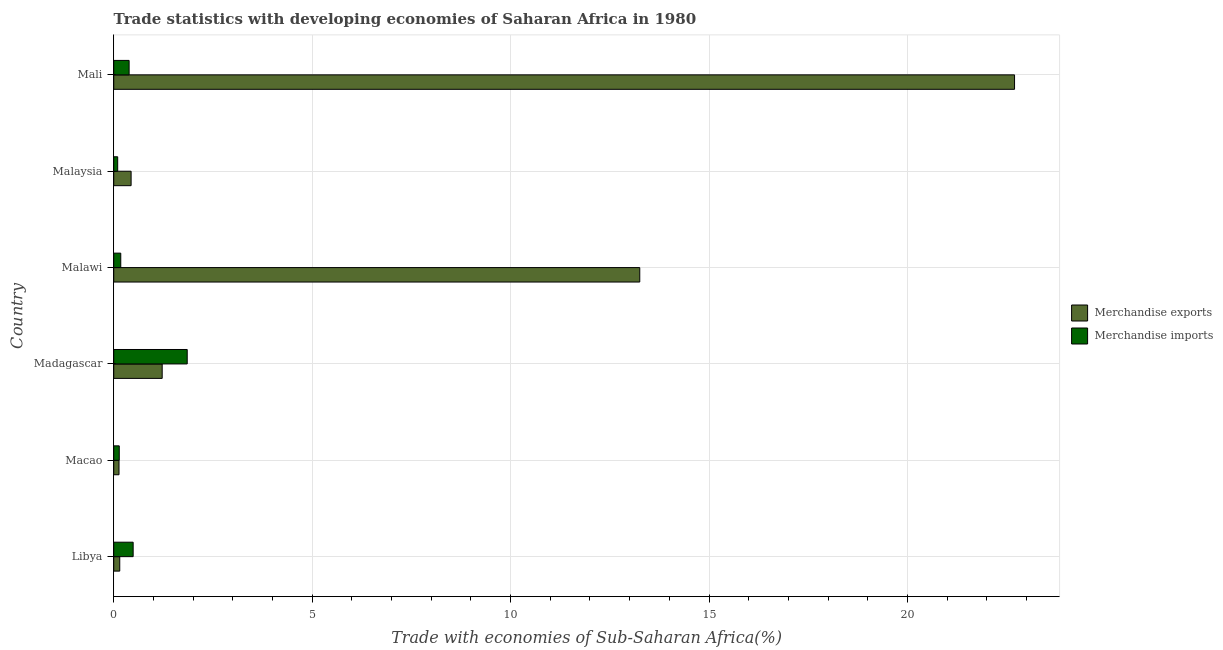How many different coloured bars are there?
Provide a short and direct response. 2. How many groups of bars are there?
Make the answer very short. 6. Are the number of bars on each tick of the Y-axis equal?
Provide a succinct answer. Yes. What is the label of the 1st group of bars from the top?
Offer a very short reply. Mali. In how many cases, is the number of bars for a given country not equal to the number of legend labels?
Provide a succinct answer. 0. What is the merchandise exports in Malawi?
Keep it short and to the point. 13.26. Across all countries, what is the maximum merchandise exports?
Keep it short and to the point. 22.7. Across all countries, what is the minimum merchandise imports?
Your response must be concise. 0.1. In which country was the merchandise exports maximum?
Offer a very short reply. Mali. In which country was the merchandise imports minimum?
Keep it short and to the point. Malaysia. What is the total merchandise imports in the graph?
Make the answer very short. 3.14. What is the difference between the merchandise imports in Mali and the merchandise exports in Macao?
Your response must be concise. 0.25. What is the average merchandise imports per country?
Your answer should be very brief. 0.52. What is the difference between the merchandise exports and merchandise imports in Mali?
Your response must be concise. 22.31. What is the ratio of the merchandise exports in Malawi to that in Malaysia?
Provide a succinct answer. 30.28. Is the difference between the merchandise imports in Libya and Malaysia greater than the difference between the merchandise exports in Libya and Malaysia?
Give a very brief answer. Yes. What is the difference between the highest and the second highest merchandise exports?
Keep it short and to the point. 9.44. What is the difference between the highest and the lowest merchandise exports?
Ensure brevity in your answer.  22.57. In how many countries, is the merchandise imports greater than the average merchandise imports taken over all countries?
Ensure brevity in your answer.  1. Is the sum of the merchandise exports in Libya and Macao greater than the maximum merchandise imports across all countries?
Offer a very short reply. No. What does the 1st bar from the top in Libya represents?
Make the answer very short. Merchandise imports. Are all the bars in the graph horizontal?
Provide a short and direct response. Yes. What is the difference between two consecutive major ticks on the X-axis?
Give a very brief answer. 5. Are the values on the major ticks of X-axis written in scientific E-notation?
Offer a very short reply. No. Does the graph contain any zero values?
Offer a very short reply. No. Where does the legend appear in the graph?
Keep it short and to the point. Center right. How many legend labels are there?
Offer a terse response. 2. What is the title of the graph?
Give a very brief answer. Trade statistics with developing economies of Saharan Africa in 1980. Does "Crop" appear as one of the legend labels in the graph?
Provide a succinct answer. No. What is the label or title of the X-axis?
Give a very brief answer. Trade with economies of Sub-Saharan Africa(%). What is the label or title of the Y-axis?
Provide a short and direct response. Country. What is the Trade with economies of Sub-Saharan Africa(%) in Merchandise exports in Libya?
Give a very brief answer. 0.15. What is the Trade with economies of Sub-Saharan Africa(%) of Merchandise imports in Libya?
Your response must be concise. 0.49. What is the Trade with economies of Sub-Saharan Africa(%) of Merchandise exports in Macao?
Offer a terse response. 0.13. What is the Trade with economies of Sub-Saharan Africa(%) of Merchandise imports in Macao?
Keep it short and to the point. 0.14. What is the Trade with economies of Sub-Saharan Africa(%) of Merchandise exports in Madagascar?
Keep it short and to the point. 1.22. What is the Trade with economies of Sub-Saharan Africa(%) of Merchandise imports in Madagascar?
Provide a short and direct response. 1.85. What is the Trade with economies of Sub-Saharan Africa(%) in Merchandise exports in Malawi?
Make the answer very short. 13.26. What is the Trade with economies of Sub-Saharan Africa(%) in Merchandise imports in Malawi?
Your answer should be very brief. 0.18. What is the Trade with economies of Sub-Saharan Africa(%) in Merchandise exports in Malaysia?
Provide a succinct answer. 0.44. What is the Trade with economies of Sub-Saharan Africa(%) of Merchandise imports in Malaysia?
Give a very brief answer. 0.1. What is the Trade with economies of Sub-Saharan Africa(%) of Merchandise exports in Mali?
Your answer should be compact. 22.7. What is the Trade with economies of Sub-Saharan Africa(%) in Merchandise imports in Mali?
Your response must be concise. 0.39. Across all countries, what is the maximum Trade with economies of Sub-Saharan Africa(%) of Merchandise exports?
Your answer should be very brief. 22.7. Across all countries, what is the maximum Trade with economies of Sub-Saharan Africa(%) in Merchandise imports?
Offer a very short reply. 1.85. Across all countries, what is the minimum Trade with economies of Sub-Saharan Africa(%) of Merchandise exports?
Your response must be concise. 0.13. Across all countries, what is the minimum Trade with economies of Sub-Saharan Africa(%) of Merchandise imports?
Your answer should be compact. 0.1. What is the total Trade with economies of Sub-Saharan Africa(%) of Merchandise exports in the graph?
Your answer should be very brief. 37.9. What is the total Trade with economies of Sub-Saharan Africa(%) of Merchandise imports in the graph?
Give a very brief answer. 3.14. What is the difference between the Trade with economies of Sub-Saharan Africa(%) in Merchandise exports in Libya and that in Macao?
Provide a succinct answer. 0.02. What is the difference between the Trade with economies of Sub-Saharan Africa(%) in Merchandise imports in Libya and that in Macao?
Give a very brief answer. 0.35. What is the difference between the Trade with economies of Sub-Saharan Africa(%) of Merchandise exports in Libya and that in Madagascar?
Ensure brevity in your answer.  -1.07. What is the difference between the Trade with economies of Sub-Saharan Africa(%) of Merchandise imports in Libya and that in Madagascar?
Make the answer very short. -1.36. What is the difference between the Trade with economies of Sub-Saharan Africa(%) in Merchandise exports in Libya and that in Malawi?
Keep it short and to the point. -13.1. What is the difference between the Trade with economies of Sub-Saharan Africa(%) of Merchandise imports in Libya and that in Malawi?
Your answer should be very brief. 0.31. What is the difference between the Trade with economies of Sub-Saharan Africa(%) in Merchandise exports in Libya and that in Malaysia?
Ensure brevity in your answer.  -0.29. What is the difference between the Trade with economies of Sub-Saharan Africa(%) in Merchandise imports in Libya and that in Malaysia?
Your answer should be very brief. 0.39. What is the difference between the Trade with economies of Sub-Saharan Africa(%) of Merchandise exports in Libya and that in Mali?
Give a very brief answer. -22.55. What is the difference between the Trade with economies of Sub-Saharan Africa(%) of Merchandise imports in Libya and that in Mali?
Your answer should be very brief. 0.1. What is the difference between the Trade with economies of Sub-Saharan Africa(%) in Merchandise exports in Macao and that in Madagascar?
Your answer should be very brief. -1.09. What is the difference between the Trade with economies of Sub-Saharan Africa(%) in Merchandise imports in Macao and that in Madagascar?
Give a very brief answer. -1.71. What is the difference between the Trade with economies of Sub-Saharan Africa(%) of Merchandise exports in Macao and that in Malawi?
Keep it short and to the point. -13.12. What is the difference between the Trade with economies of Sub-Saharan Africa(%) of Merchandise imports in Macao and that in Malawi?
Make the answer very short. -0.04. What is the difference between the Trade with economies of Sub-Saharan Africa(%) of Merchandise exports in Macao and that in Malaysia?
Your response must be concise. -0.3. What is the difference between the Trade with economies of Sub-Saharan Africa(%) in Merchandise exports in Macao and that in Mali?
Your response must be concise. -22.57. What is the difference between the Trade with economies of Sub-Saharan Africa(%) in Merchandise imports in Macao and that in Mali?
Provide a short and direct response. -0.25. What is the difference between the Trade with economies of Sub-Saharan Africa(%) of Merchandise exports in Madagascar and that in Malawi?
Offer a very short reply. -12.03. What is the difference between the Trade with economies of Sub-Saharan Africa(%) of Merchandise imports in Madagascar and that in Malawi?
Offer a terse response. 1.67. What is the difference between the Trade with economies of Sub-Saharan Africa(%) of Merchandise exports in Madagascar and that in Malaysia?
Your answer should be very brief. 0.78. What is the difference between the Trade with economies of Sub-Saharan Africa(%) of Merchandise imports in Madagascar and that in Malaysia?
Your response must be concise. 1.75. What is the difference between the Trade with economies of Sub-Saharan Africa(%) in Merchandise exports in Madagascar and that in Mali?
Your answer should be compact. -21.48. What is the difference between the Trade with economies of Sub-Saharan Africa(%) in Merchandise imports in Madagascar and that in Mali?
Your answer should be very brief. 1.46. What is the difference between the Trade with economies of Sub-Saharan Africa(%) of Merchandise exports in Malawi and that in Malaysia?
Your response must be concise. 12.82. What is the difference between the Trade with economies of Sub-Saharan Africa(%) of Merchandise imports in Malawi and that in Malaysia?
Give a very brief answer. 0.08. What is the difference between the Trade with economies of Sub-Saharan Africa(%) of Merchandise exports in Malawi and that in Mali?
Your answer should be compact. -9.44. What is the difference between the Trade with economies of Sub-Saharan Africa(%) in Merchandise imports in Malawi and that in Mali?
Provide a succinct answer. -0.21. What is the difference between the Trade with economies of Sub-Saharan Africa(%) in Merchandise exports in Malaysia and that in Mali?
Offer a very short reply. -22.26. What is the difference between the Trade with economies of Sub-Saharan Africa(%) in Merchandise imports in Malaysia and that in Mali?
Ensure brevity in your answer.  -0.29. What is the difference between the Trade with economies of Sub-Saharan Africa(%) in Merchandise exports in Libya and the Trade with economies of Sub-Saharan Africa(%) in Merchandise imports in Macao?
Your response must be concise. 0.01. What is the difference between the Trade with economies of Sub-Saharan Africa(%) of Merchandise exports in Libya and the Trade with economies of Sub-Saharan Africa(%) of Merchandise imports in Madagascar?
Make the answer very short. -1.7. What is the difference between the Trade with economies of Sub-Saharan Africa(%) of Merchandise exports in Libya and the Trade with economies of Sub-Saharan Africa(%) of Merchandise imports in Malawi?
Make the answer very short. -0.03. What is the difference between the Trade with economies of Sub-Saharan Africa(%) of Merchandise exports in Libya and the Trade with economies of Sub-Saharan Africa(%) of Merchandise imports in Malaysia?
Ensure brevity in your answer.  0.05. What is the difference between the Trade with economies of Sub-Saharan Africa(%) in Merchandise exports in Libya and the Trade with economies of Sub-Saharan Africa(%) in Merchandise imports in Mali?
Provide a succinct answer. -0.24. What is the difference between the Trade with economies of Sub-Saharan Africa(%) of Merchandise exports in Macao and the Trade with economies of Sub-Saharan Africa(%) of Merchandise imports in Madagascar?
Provide a succinct answer. -1.72. What is the difference between the Trade with economies of Sub-Saharan Africa(%) in Merchandise exports in Macao and the Trade with economies of Sub-Saharan Africa(%) in Merchandise imports in Malawi?
Make the answer very short. -0.04. What is the difference between the Trade with economies of Sub-Saharan Africa(%) of Merchandise exports in Macao and the Trade with economies of Sub-Saharan Africa(%) of Merchandise imports in Malaysia?
Provide a short and direct response. 0.03. What is the difference between the Trade with economies of Sub-Saharan Africa(%) of Merchandise exports in Macao and the Trade with economies of Sub-Saharan Africa(%) of Merchandise imports in Mali?
Your answer should be very brief. -0.25. What is the difference between the Trade with economies of Sub-Saharan Africa(%) in Merchandise exports in Madagascar and the Trade with economies of Sub-Saharan Africa(%) in Merchandise imports in Malawi?
Make the answer very short. 1.04. What is the difference between the Trade with economies of Sub-Saharan Africa(%) in Merchandise exports in Madagascar and the Trade with economies of Sub-Saharan Africa(%) in Merchandise imports in Malaysia?
Offer a terse response. 1.12. What is the difference between the Trade with economies of Sub-Saharan Africa(%) of Merchandise exports in Madagascar and the Trade with economies of Sub-Saharan Africa(%) of Merchandise imports in Mali?
Your answer should be compact. 0.83. What is the difference between the Trade with economies of Sub-Saharan Africa(%) in Merchandise exports in Malawi and the Trade with economies of Sub-Saharan Africa(%) in Merchandise imports in Malaysia?
Your response must be concise. 13.16. What is the difference between the Trade with economies of Sub-Saharan Africa(%) in Merchandise exports in Malawi and the Trade with economies of Sub-Saharan Africa(%) in Merchandise imports in Mali?
Your response must be concise. 12.87. What is the difference between the Trade with economies of Sub-Saharan Africa(%) in Merchandise exports in Malaysia and the Trade with economies of Sub-Saharan Africa(%) in Merchandise imports in Mali?
Give a very brief answer. 0.05. What is the average Trade with economies of Sub-Saharan Africa(%) in Merchandise exports per country?
Make the answer very short. 6.32. What is the average Trade with economies of Sub-Saharan Africa(%) in Merchandise imports per country?
Make the answer very short. 0.52. What is the difference between the Trade with economies of Sub-Saharan Africa(%) of Merchandise exports and Trade with economies of Sub-Saharan Africa(%) of Merchandise imports in Libya?
Your answer should be very brief. -0.34. What is the difference between the Trade with economies of Sub-Saharan Africa(%) of Merchandise exports and Trade with economies of Sub-Saharan Africa(%) of Merchandise imports in Macao?
Offer a terse response. -0.01. What is the difference between the Trade with economies of Sub-Saharan Africa(%) in Merchandise exports and Trade with economies of Sub-Saharan Africa(%) in Merchandise imports in Madagascar?
Your answer should be very brief. -0.63. What is the difference between the Trade with economies of Sub-Saharan Africa(%) in Merchandise exports and Trade with economies of Sub-Saharan Africa(%) in Merchandise imports in Malawi?
Offer a very short reply. 13.08. What is the difference between the Trade with economies of Sub-Saharan Africa(%) of Merchandise exports and Trade with economies of Sub-Saharan Africa(%) of Merchandise imports in Malaysia?
Provide a succinct answer. 0.34. What is the difference between the Trade with economies of Sub-Saharan Africa(%) of Merchandise exports and Trade with economies of Sub-Saharan Africa(%) of Merchandise imports in Mali?
Your response must be concise. 22.31. What is the ratio of the Trade with economies of Sub-Saharan Africa(%) in Merchandise exports in Libya to that in Macao?
Your answer should be very brief. 1.14. What is the ratio of the Trade with economies of Sub-Saharan Africa(%) in Merchandise imports in Libya to that in Macao?
Offer a very short reply. 3.51. What is the ratio of the Trade with economies of Sub-Saharan Africa(%) of Merchandise exports in Libya to that in Madagascar?
Provide a succinct answer. 0.12. What is the ratio of the Trade with economies of Sub-Saharan Africa(%) of Merchandise imports in Libya to that in Madagascar?
Provide a succinct answer. 0.26. What is the ratio of the Trade with economies of Sub-Saharan Africa(%) in Merchandise exports in Libya to that in Malawi?
Provide a succinct answer. 0.01. What is the ratio of the Trade with economies of Sub-Saharan Africa(%) of Merchandise imports in Libya to that in Malawi?
Make the answer very short. 2.76. What is the ratio of the Trade with economies of Sub-Saharan Africa(%) in Merchandise exports in Libya to that in Malaysia?
Your answer should be compact. 0.35. What is the ratio of the Trade with economies of Sub-Saharan Africa(%) of Merchandise imports in Libya to that in Malaysia?
Your response must be concise. 4.93. What is the ratio of the Trade with economies of Sub-Saharan Africa(%) in Merchandise exports in Libya to that in Mali?
Your answer should be compact. 0.01. What is the ratio of the Trade with economies of Sub-Saharan Africa(%) in Merchandise imports in Libya to that in Mali?
Make the answer very short. 1.26. What is the ratio of the Trade with economies of Sub-Saharan Africa(%) of Merchandise exports in Macao to that in Madagascar?
Your answer should be very brief. 0.11. What is the ratio of the Trade with economies of Sub-Saharan Africa(%) of Merchandise imports in Macao to that in Madagascar?
Keep it short and to the point. 0.08. What is the ratio of the Trade with economies of Sub-Saharan Africa(%) of Merchandise imports in Macao to that in Malawi?
Your answer should be very brief. 0.79. What is the ratio of the Trade with economies of Sub-Saharan Africa(%) in Merchandise exports in Macao to that in Malaysia?
Make the answer very short. 0.3. What is the ratio of the Trade with economies of Sub-Saharan Africa(%) of Merchandise imports in Macao to that in Malaysia?
Give a very brief answer. 1.4. What is the ratio of the Trade with economies of Sub-Saharan Africa(%) in Merchandise exports in Macao to that in Mali?
Your answer should be very brief. 0.01. What is the ratio of the Trade with economies of Sub-Saharan Africa(%) of Merchandise imports in Macao to that in Mali?
Offer a very short reply. 0.36. What is the ratio of the Trade with economies of Sub-Saharan Africa(%) of Merchandise exports in Madagascar to that in Malawi?
Your response must be concise. 0.09. What is the ratio of the Trade with economies of Sub-Saharan Africa(%) of Merchandise imports in Madagascar to that in Malawi?
Offer a terse response. 10.46. What is the ratio of the Trade with economies of Sub-Saharan Africa(%) of Merchandise exports in Madagascar to that in Malaysia?
Keep it short and to the point. 2.79. What is the ratio of the Trade with economies of Sub-Saharan Africa(%) in Merchandise imports in Madagascar to that in Malaysia?
Provide a short and direct response. 18.65. What is the ratio of the Trade with economies of Sub-Saharan Africa(%) in Merchandise exports in Madagascar to that in Mali?
Keep it short and to the point. 0.05. What is the ratio of the Trade with economies of Sub-Saharan Africa(%) in Merchandise imports in Madagascar to that in Mali?
Your answer should be very brief. 4.78. What is the ratio of the Trade with economies of Sub-Saharan Africa(%) in Merchandise exports in Malawi to that in Malaysia?
Your answer should be very brief. 30.28. What is the ratio of the Trade with economies of Sub-Saharan Africa(%) in Merchandise imports in Malawi to that in Malaysia?
Your answer should be very brief. 1.78. What is the ratio of the Trade with economies of Sub-Saharan Africa(%) in Merchandise exports in Malawi to that in Mali?
Offer a very short reply. 0.58. What is the ratio of the Trade with economies of Sub-Saharan Africa(%) of Merchandise imports in Malawi to that in Mali?
Your answer should be compact. 0.46. What is the ratio of the Trade with economies of Sub-Saharan Africa(%) in Merchandise exports in Malaysia to that in Mali?
Your answer should be compact. 0.02. What is the ratio of the Trade with economies of Sub-Saharan Africa(%) of Merchandise imports in Malaysia to that in Mali?
Ensure brevity in your answer.  0.26. What is the difference between the highest and the second highest Trade with economies of Sub-Saharan Africa(%) in Merchandise exports?
Provide a succinct answer. 9.44. What is the difference between the highest and the second highest Trade with economies of Sub-Saharan Africa(%) in Merchandise imports?
Give a very brief answer. 1.36. What is the difference between the highest and the lowest Trade with economies of Sub-Saharan Africa(%) of Merchandise exports?
Offer a very short reply. 22.57. What is the difference between the highest and the lowest Trade with economies of Sub-Saharan Africa(%) in Merchandise imports?
Your answer should be compact. 1.75. 